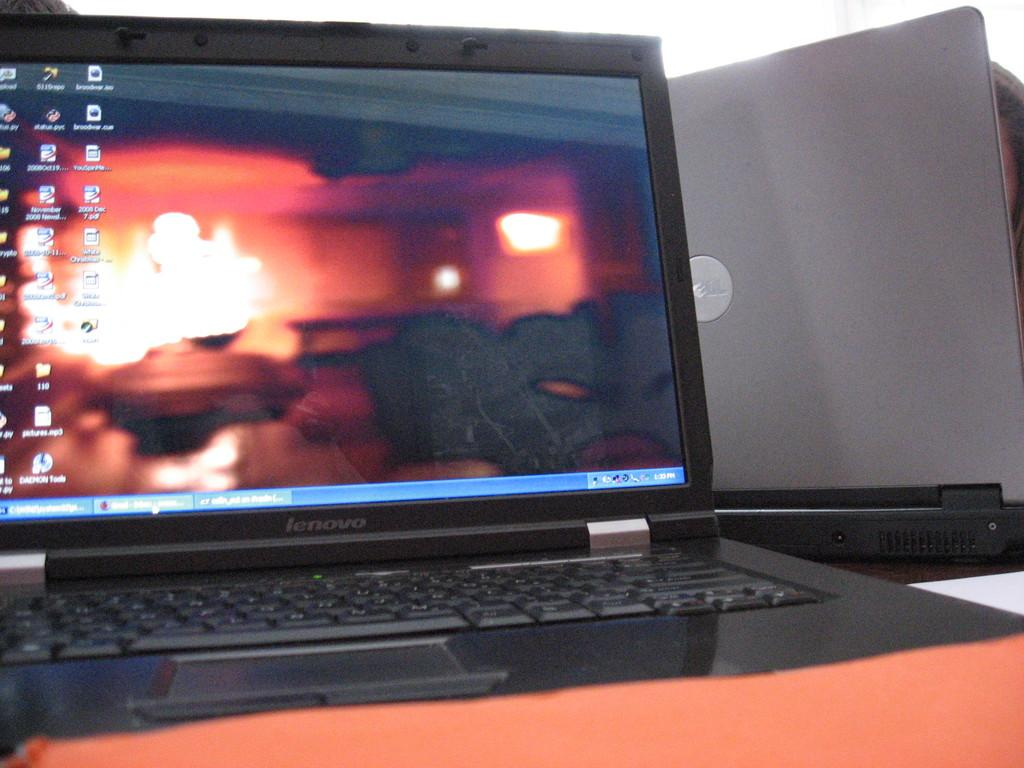<image>
Render a clear and concise summary of the photo. The black laptop on the table reads lenovo 